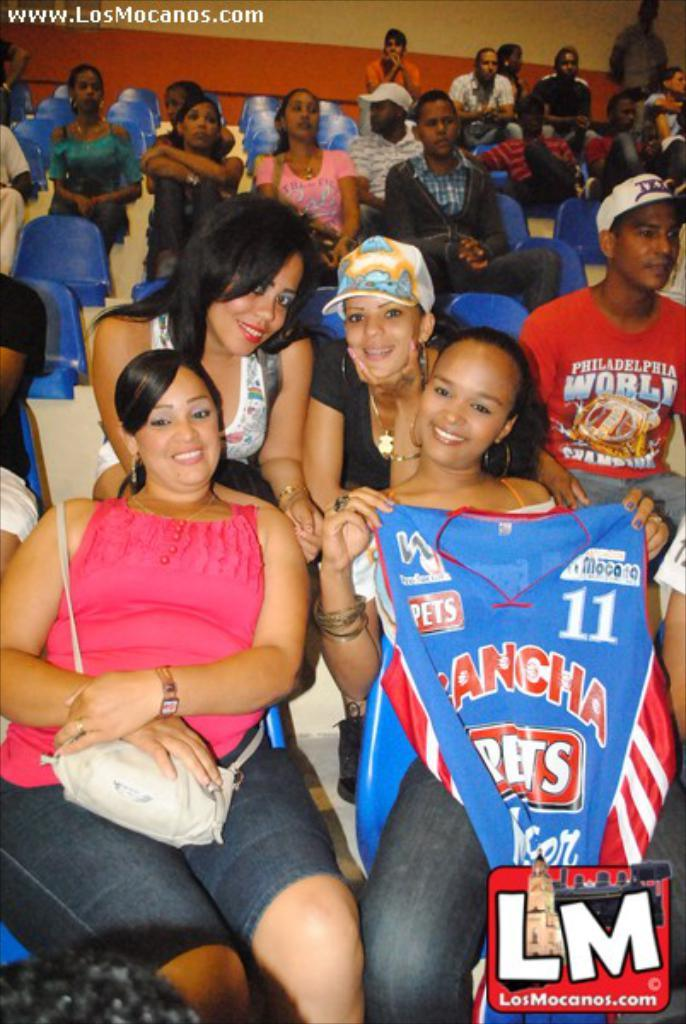Provide a one-sentence caption for the provided image. A stadium full of people and a woman among them is holding a shirt that says Rancha. 